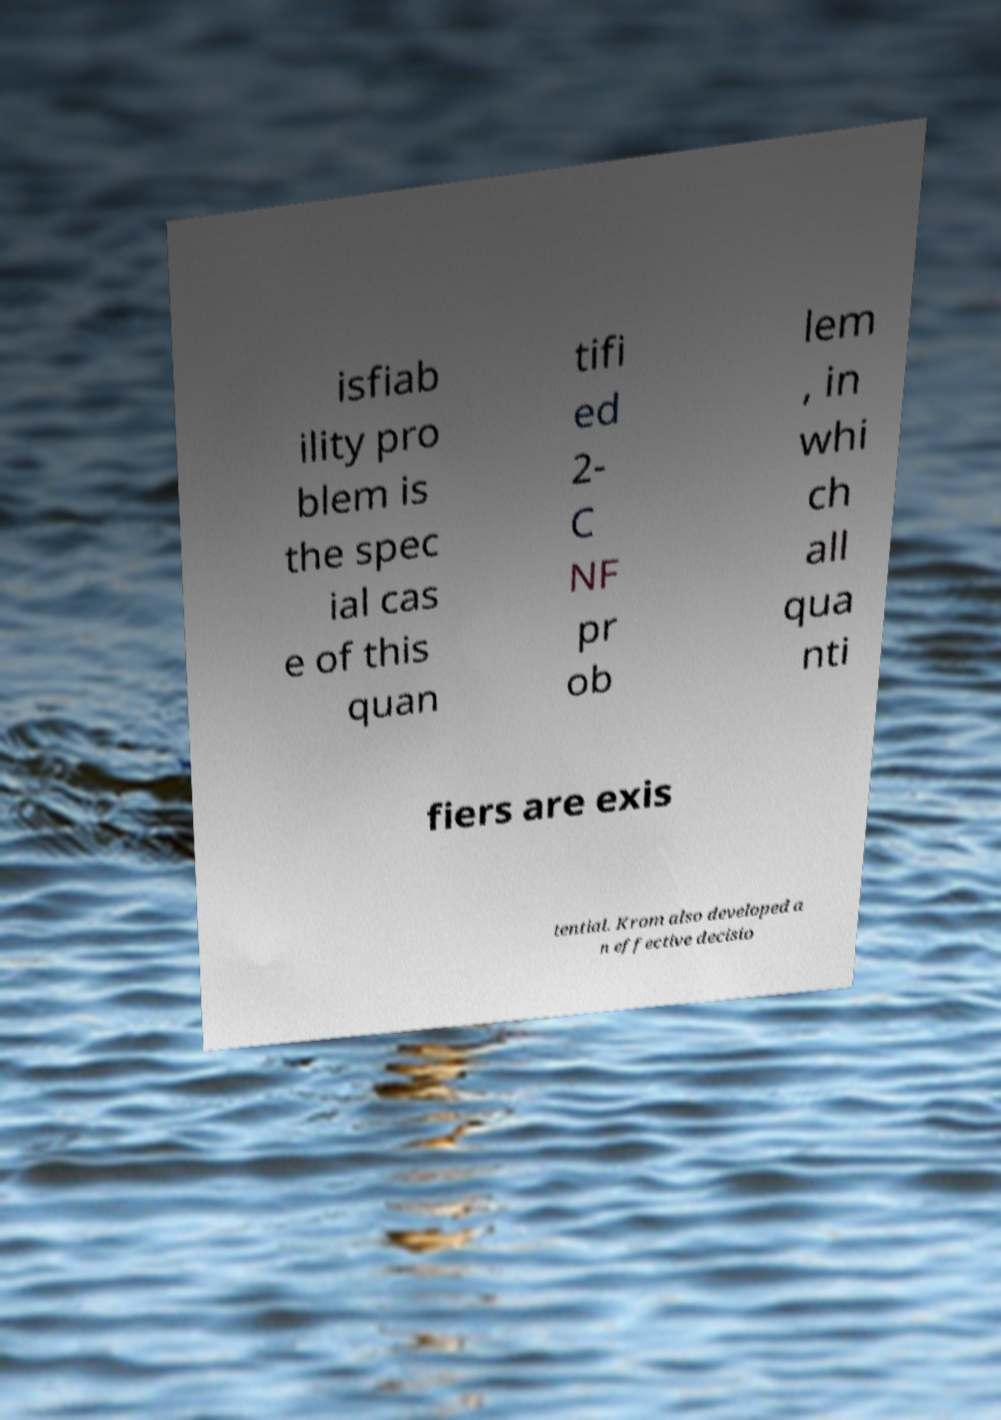What messages or text are displayed in this image? I need them in a readable, typed format. isfiab ility pro blem is the spec ial cas e of this quan tifi ed 2- C NF pr ob lem , in whi ch all qua nti fiers are exis tential. Krom also developed a n effective decisio 